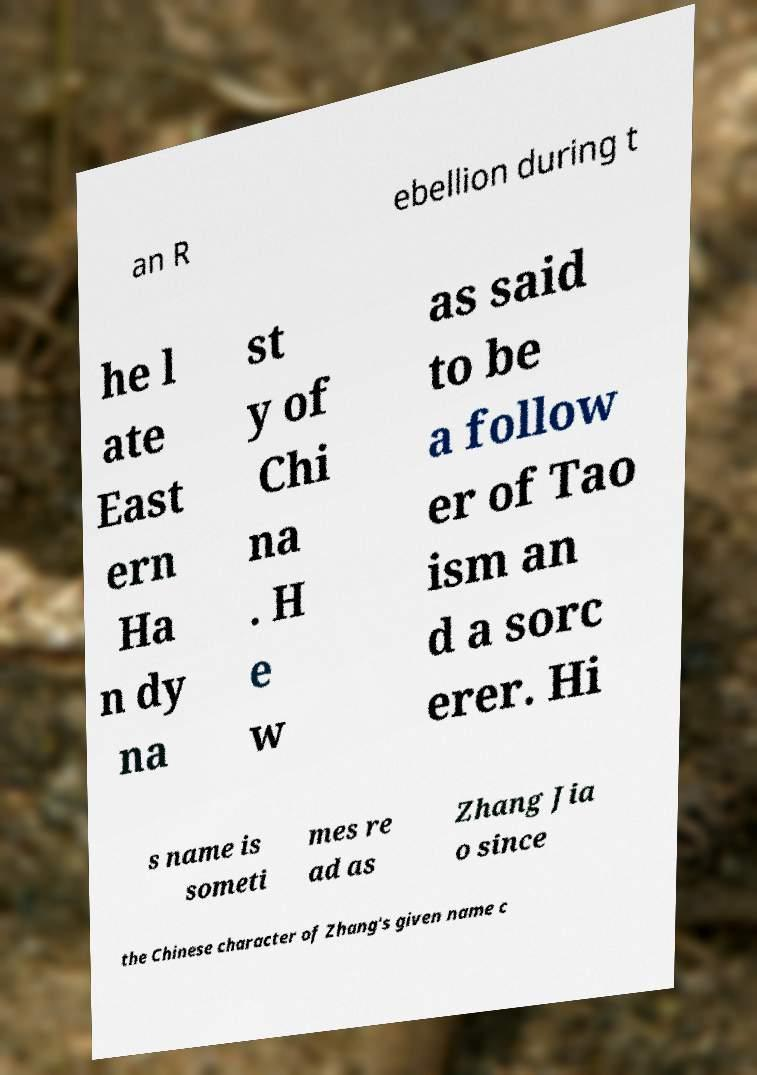What messages or text are displayed in this image? I need them in a readable, typed format. an R ebellion during t he l ate East ern Ha n dy na st y of Chi na . H e w as said to be a follow er of Tao ism an d a sorc erer. Hi s name is someti mes re ad as Zhang Jia o since the Chinese character of Zhang's given name c 